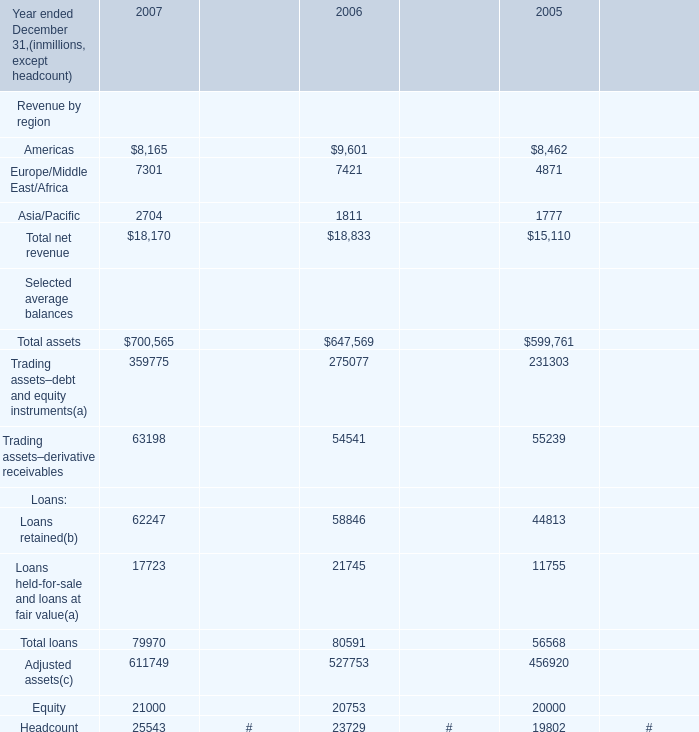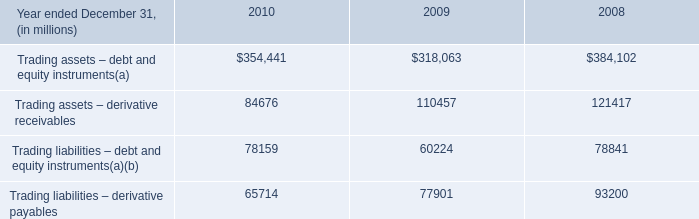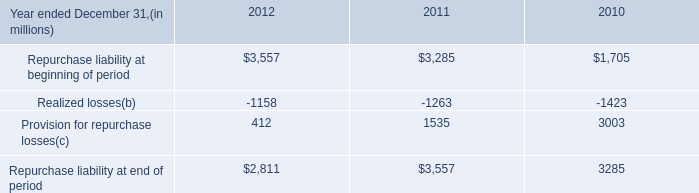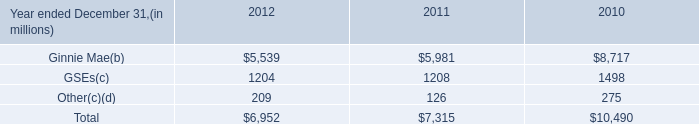What will Asia/Pacific reach in 2008 if it continues to grow at its current rate? (in million) 
Computations: (2704 * (1 + ((2704 - 1811) / 1811)))
Answer: 4037.33628. 